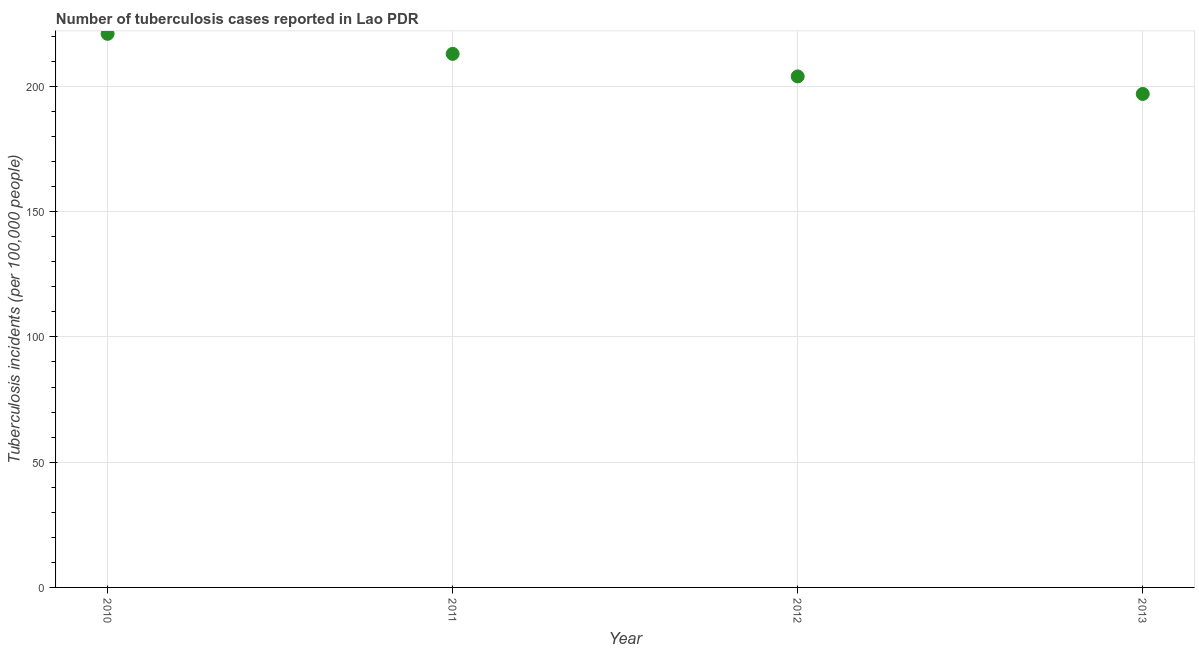What is the number of tuberculosis incidents in 2010?
Offer a very short reply. 221. Across all years, what is the maximum number of tuberculosis incidents?
Give a very brief answer. 221. Across all years, what is the minimum number of tuberculosis incidents?
Ensure brevity in your answer.  197. In which year was the number of tuberculosis incidents maximum?
Give a very brief answer. 2010. What is the sum of the number of tuberculosis incidents?
Offer a very short reply. 835. What is the difference between the number of tuberculosis incidents in 2010 and 2012?
Provide a short and direct response. 17. What is the average number of tuberculosis incidents per year?
Provide a succinct answer. 208.75. What is the median number of tuberculosis incidents?
Ensure brevity in your answer.  208.5. Do a majority of the years between 2011 and 2010 (inclusive) have number of tuberculosis incidents greater than 40 ?
Offer a terse response. No. What is the ratio of the number of tuberculosis incidents in 2010 to that in 2011?
Your answer should be compact. 1.04. What is the difference between the highest and the second highest number of tuberculosis incidents?
Provide a succinct answer. 8. Is the sum of the number of tuberculosis incidents in 2010 and 2012 greater than the maximum number of tuberculosis incidents across all years?
Your response must be concise. Yes. What is the difference between the highest and the lowest number of tuberculosis incidents?
Offer a very short reply. 24. In how many years, is the number of tuberculosis incidents greater than the average number of tuberculosis incidents taken over all years?
Your answer should be compact. 2. How many years are there in the graph?
Ensure brevity in your answer.  4. Are the values on the major ticks of Y-axis written in scientific E-notation?
Your answer should be very brief. No. Does the graph contain grids?
Provide a succinct answer. Yes. What is the title of the graph?
Your answer should be very brief. Number of tuberculosis cases reported in Lao PDR. What is the label or title of the Y-axis?
Make the answer very short. Tuberculosis incidents (per 100,0 people). What is the Tuberculosis incidents (per 100,000 people) in 2010?
Provide a short and direct response. 221. What is the Tuberculosis incidents (per 100,000 people) in 2011?
Provide a short and direct response. 213. What is the Tuberculosis incidents (per 100,000 people) in 2012?
Offer a very short reply. 204. What is the Tuberculosis incidents (per 100,000 people) in 2013?
Your answer should be compact. 197. What is the difference between the Tuberculosis incidents (per 100,000 people) in 2010 and 2012?
Give a very brief answer. 17. What is the difference between the Tuberculosis incidents (per 100,000 people) in 2010 and 2013?
Give a very brief answer. 24. What is the difference between the Tuberculosis incidents (per 100,000 people) in 2011 and 2012?
Offer a very short reply. 9. What is the difference between the Tuberculosis incidents (per 100,000 people) in 2011 and 2013?
Your answer should be compact. 16. What is the difference between the Tuberculosis incidents (per 100,000 people) in 2012 and 2013?
Your answer should be compact. 7. What is the ratio of the Tuberculosis incidents (per 100,000 people) in 2010 to that in 2011?
Give a very brief answer. 1.04. What is the ratio of the Tuberculosis incidents (per 100,000 people) in 2010 to that in 2012?
Provide a short and direct response. 1.08. What is the ratio of the Tuberculosis incidents (per 100,000 people) in 2010 to that in 2013?
Keep it short and to the point. 1.12. What is the ratio of the Tuberculosis incidents (per 100,000 people) in 2011 to that in 2012?
Provide a short and direct response. 1.04. What is the ratio of the Tuberculosis incidents (per 100,000 people) in 2011 to that in 2013?
Keep it short and to the point. 1.08. What is the ratio of the Tuberculosis incidents (per 100,000 people) in 2012 to that in 2013?
Make the answer very short. 1.04. 